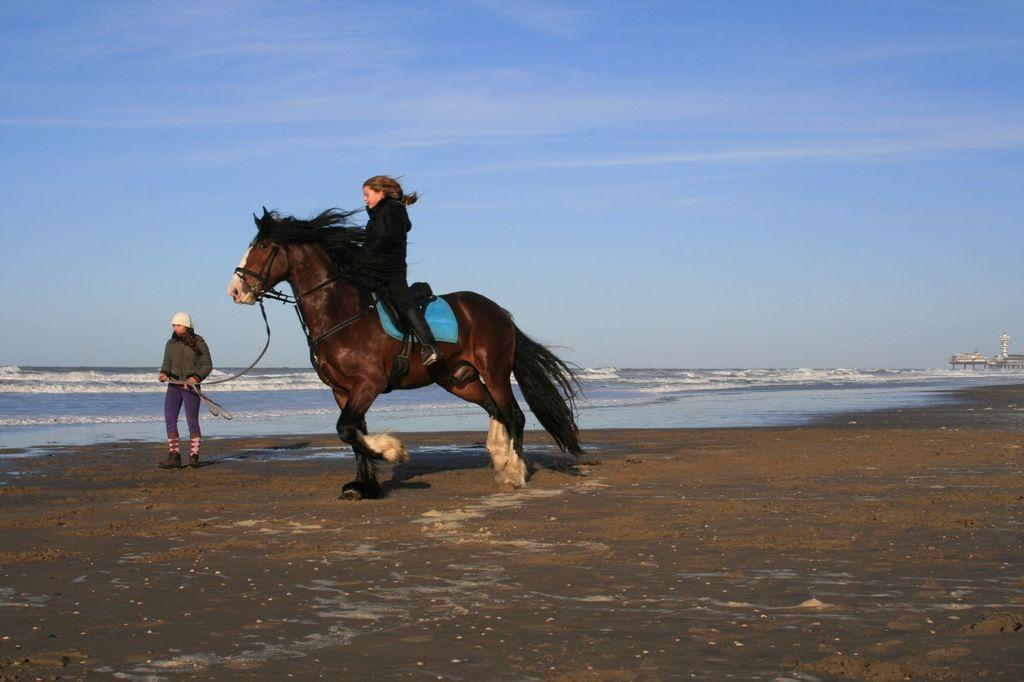What is the girl doing in the image? The girl is riding a horse in the image. Where is the horse located? The horse is on a path in the image. What is the person standing beside the horse doing? The person is holding a rope attached to the horse. What can be seen in the background of the image? There is a river and the sky visible in the background of the image. Can you tell me how many crows are sitting on the faucet in the image? There is no faucet or crow present in the image. What expertise does the person standing beside the horse have in the image? The facts provided do not mention any specific expertise of the person standing beside the horse. 